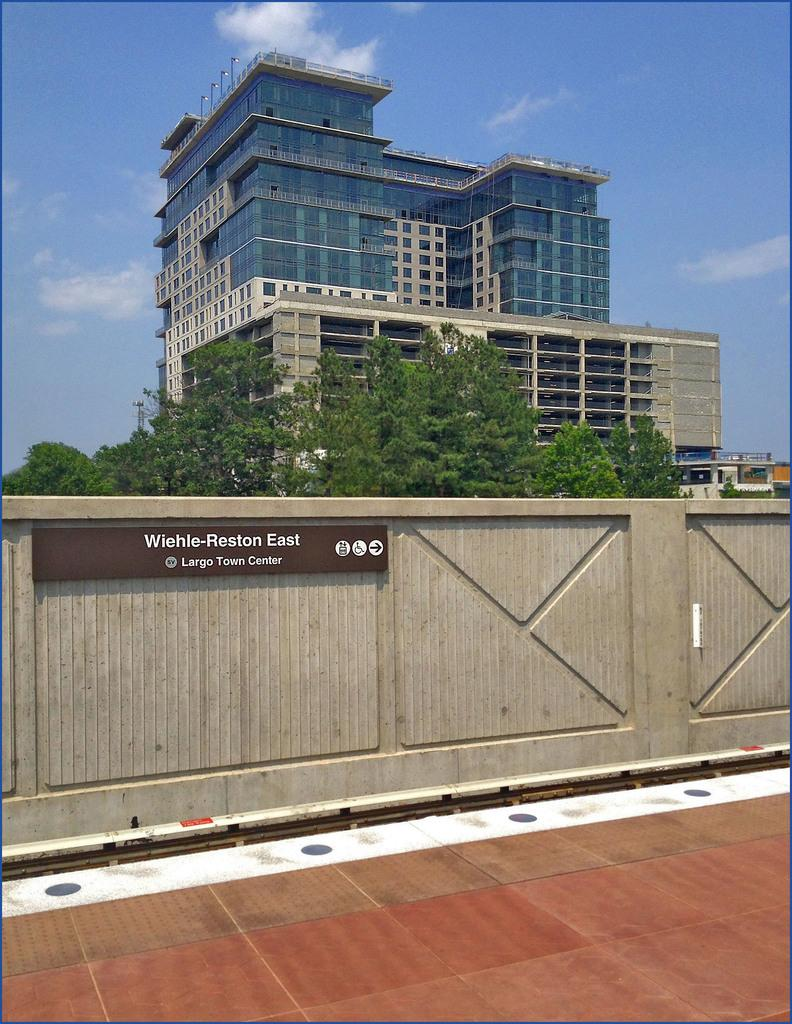What is visible on the ground in the image? The ground is visible in the image. What type of vegetation can be seen in the image? There are trees in the image. What type of structure is present in the image? There is a building in the image. What is written on the wall in the image? There is a name board on a wall in the image. What is visible in the background of the image? The sky is visible in the background of the image. What can be seen in the sky in the image? Clouds are present in the sky. What type of furniture is being sneezed on in the image? There is no furniture or sneezing present in the image. 